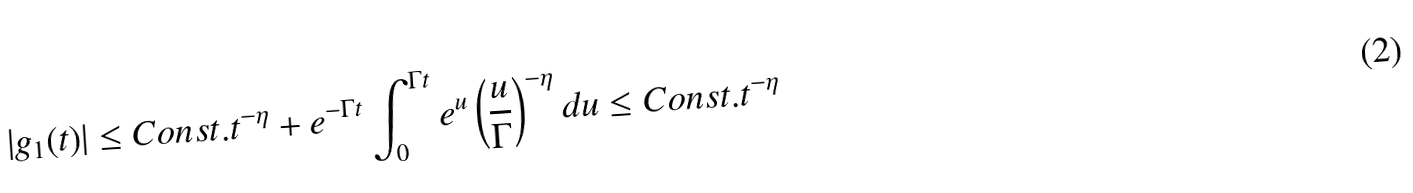Convert formula to latex. <formula><loc_0><loc_0><loc_500><loc_500>| g _ { 1 } ( t ) | \leq C o n s t . t ^ { - \eta } + e ^ { - \Gamma t } \int _ { 0 } ^ { \Gamma t } e ^ { u } \left ( \frac { u } { \Gamma } \right ) ^ { - \eta } d u \leq C o n s t . t ^ { - \eta }</formula> 